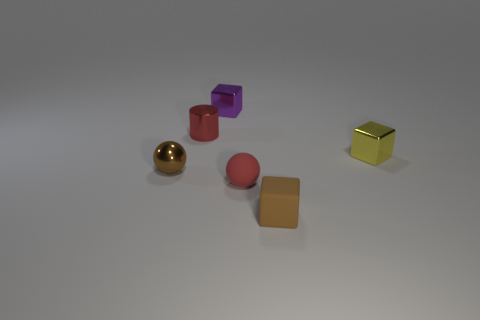There is a metal cube that is left of the brown object in front of the brown ball; what size is it?
Provide a short and direct response. Small. There is a brown ball that is the same size as the purple metallic cube; what is it made of?
Offer a terse response. Metal. What number of other things are there of the same size as the brown metallic ball?
Ensure brevity in your answer.  5. How many cylinders are small brown matte objects or purple metallic things?
Provide a succinct answer. 0. Are there any other things that are made of the same material as the tiny cylinder?
Offer a terse response. Yes. What material is the ball that is right of the tiny red shiny thing that is to the left of the cube that is in front of the tiny yellow shiny object made of?
Your answer should be very brief. Rubber. What is the material of the thing that is the same color as the metal sphere?
Offer a terse response. Rubber. How many red balls have the same material as the small yellow block?
Give a very brief answer. 0. Does the metallic cube that is to the right of the red matte sphere have the same size as the tiny red metal cylinder?
Make the answer very short. Yes. The small sphere that is made of the same material as the tiny cylinder is what color?
Provide a succinct answer. Brown. 